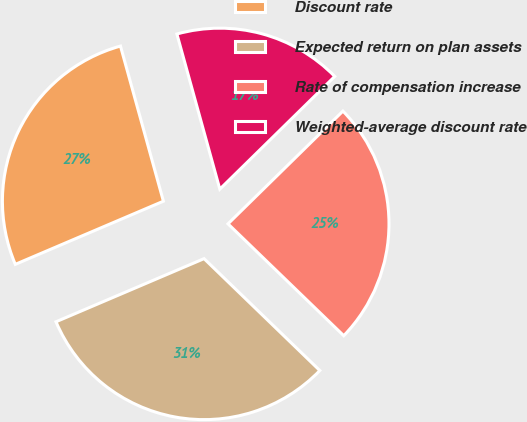<chart> <loc_0><loc_0><loc_500><loc_500><pie_chart><fcel>Discount rate<fcel>Expected return on plan assets<fcel>Rate of compensation increase<fcel>Weighted-average discount rate<nl><fcel>27.12%<fcel>31.36%<fcel>24.58%<fcel>16.95%<nl></chart> 